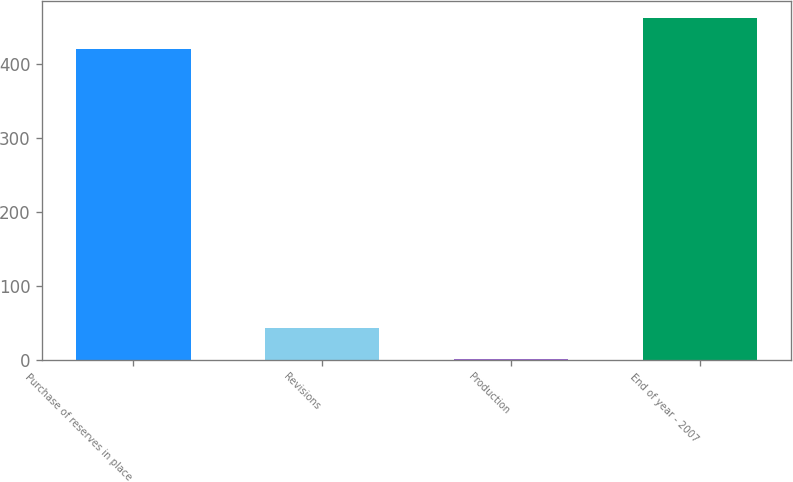<chart> <loc_0><loc_0><loc_500><loc_500><bar_chart><fcel>Purchase of reserves in place<fcel>Revisions<fcel>Production<fcel>End of year - 2007<nl><fcel>420<fcel>43<fcel>1<fcel>462<nl></chart> 